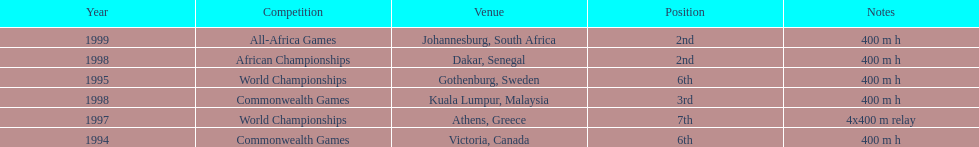What venue came before gothenburg, sweden? Victoria, Canada. 